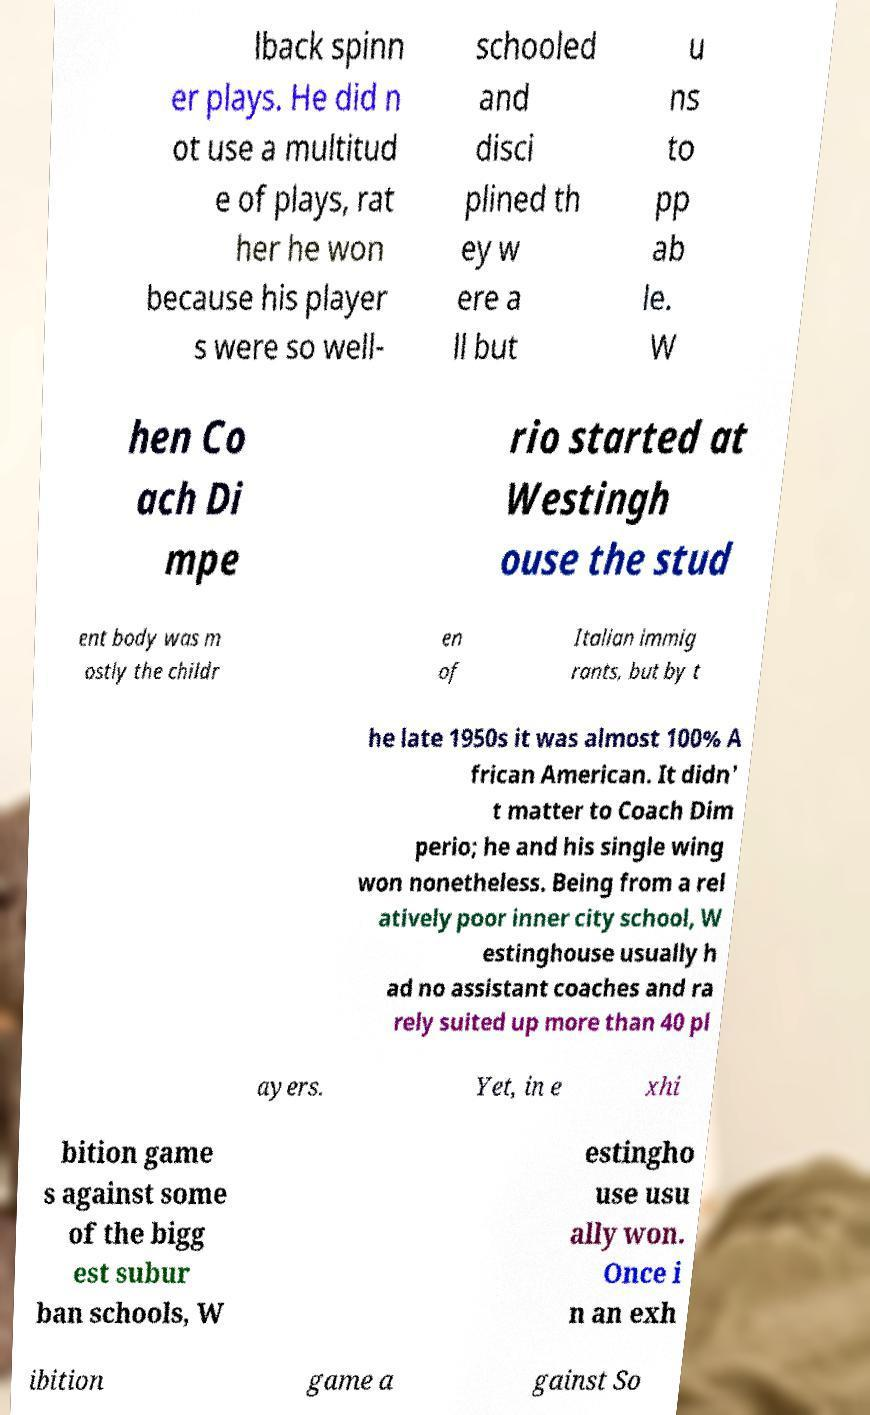What messages or text are displayed in this image? I need them in a readable, typed format. lback spinn er plays. He did n ot use a multitud e of plays, rat her he won because his player s were so well- schooled and disci plined th ey w ere a ll but u ns to pp ab le. W hen Co ach Di mpe rio started at Westingh ouse the stud ent body was m ostly the childr en of Italian immig rants, but by t he late 1950s it was almost 100% A frican American. It didn' t matter to Coach Dim perio; he and his single wing won nonetheless. Being from a rel atively poor inner city school, W estinghouse usually h ad no assistant coaches and ra rely suited up more than 40 pl ayers. Yet, in e xhi bition game s against some of the bigg est subur ban schools, W estingho use usu ally won. Once i n an exh ibition game a gainst So 